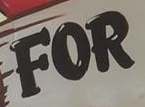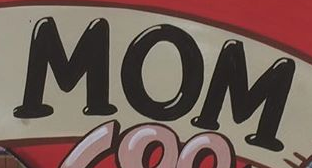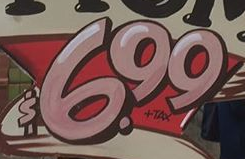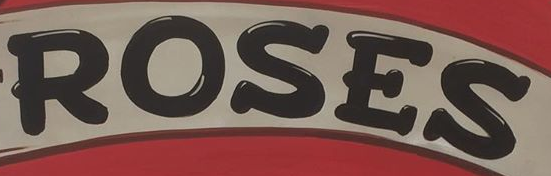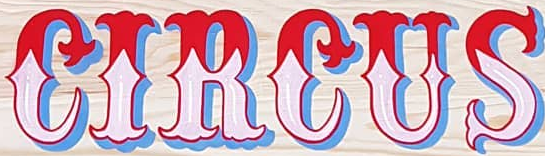What text is displayed in these images sequentially, separated by a semicolon? FOR; MOM; $6.99; ROSES; CIRCUS 